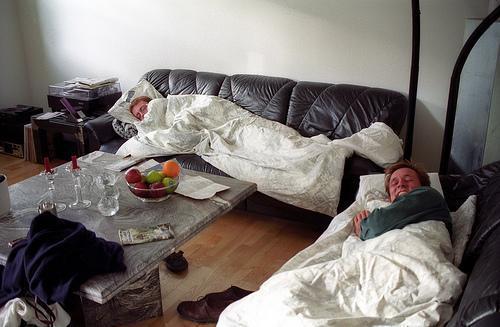How many people are in the scene?
Give a very brief answer. 2. 